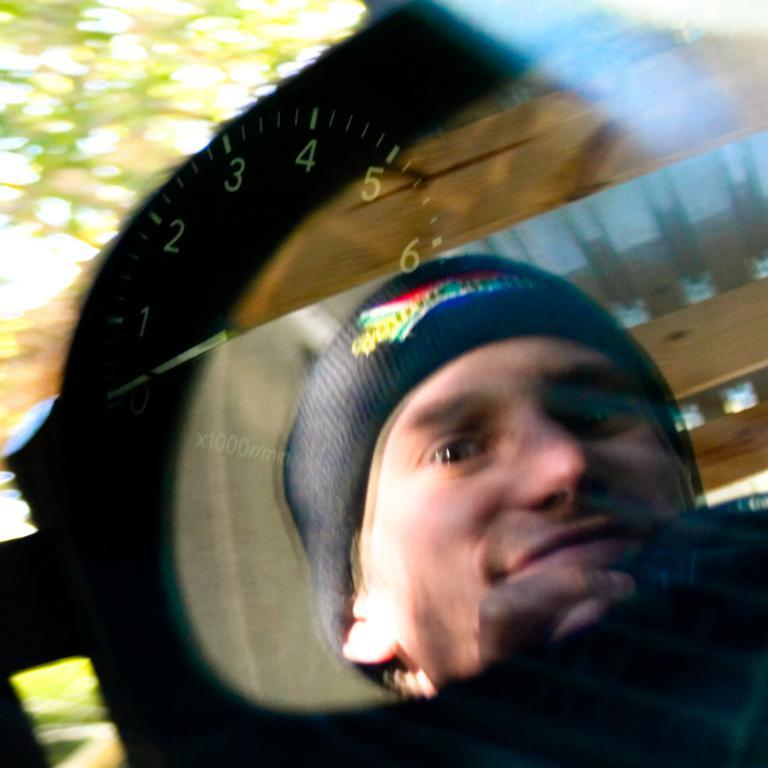What is the main object in the image? There is a meter indicator in the image. How is the meter indicator protected? The meter indicator is covered with a glass. Can you describe the reflection on the glass? There is a reflection of a person wearing a cap on the glass. What can be seen in the background of the image? There are trees in the background of the image. What type of glove is the person wearing in the image? There is no glove visible in the image; the reflection on the glass shows a person wearing a cap. What type of war is depicted in the image? There is no war depicted in the image; it features a meter indicator with a glass cover and a reflection of a person wearing a cap. 